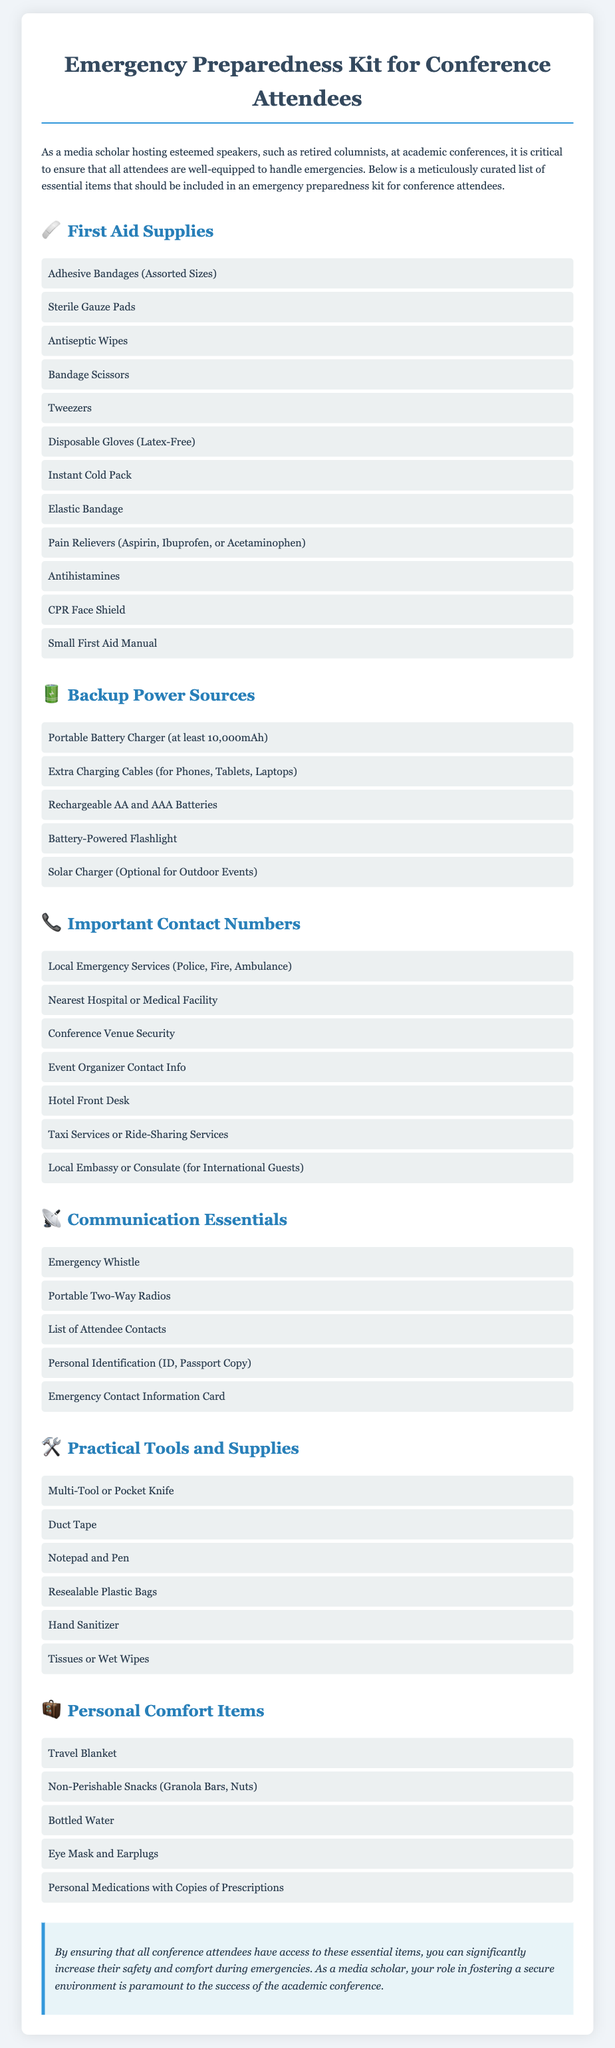What is the title of the document? The title of the document is presented in the heading at the top of the rendered document.
Answer: Emergency Preparedness Kit for Conference Attendees How many categories of items are listed? The document lists several categories under which items are categorized, and counting them provides the total.
Answer: Six What item is listed under First Aid Supplies? The document provides a list of items under the First Aid Supplies category, and querying one will provide a specific example.
Answer: Adhesive Bandages (Assorted Sizes) What contact number is suggested to include for emergencies? The section on Important Contact Numbers suggests essential contacts required during emergencies, such as a police, fire, or ambulance service.
Answer: Local Emergency Services (Police, Fire, Ambulance) Which item is recommended for backup power? The document explicitly mentions items listed under Backup Power Sources, asking for a specific example yields a direct answer.
Answer: Portable Battery Charger (at least 10,000mAh) What type of snacks should be included in the Personal Comfort Items? The document outlines what types of snacks are suggested and specifying a type will direct to a relevant example.
Answer: Non-Perishable Snacks (Granola Bars, Nuts) What practical tool is mentioned in the document? The document highlights several items under Practical Tools and Supplies, and asking for a specific tool will produce an example.
Answer: Multi-Tool or Pocket Knife How many items are listed under Communication Essentials? This is a numerical inquiry, which can be answered by counting the items listed in the Communication Essentials section of the document.
Answer: Five 